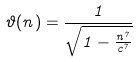<formula> <loc_0><loc_0><loc_500><loc_500>\vartheta ( n ) = \frac { 1 } { \sqrt { 1 - \frac { n ^ { 7 } } { c ^ { 7 } } } }</formula> 